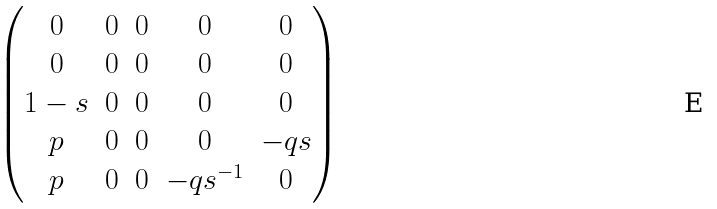<formula> <loc_0><loc_0><loc_500><loc_500>\begin{pmatrix} 0 & 0 & 0 & 0 & 0 \\ 0 & 0 & 0 & 0 & 0 \\ 1 - s & 0 & 0 & 0 & 0 \\ p & 0 & 0 & 0 & - q s \\ p & 0 & 0 & - q s ^ { - 1 } & 0 \end{pmatrix}</formula> 